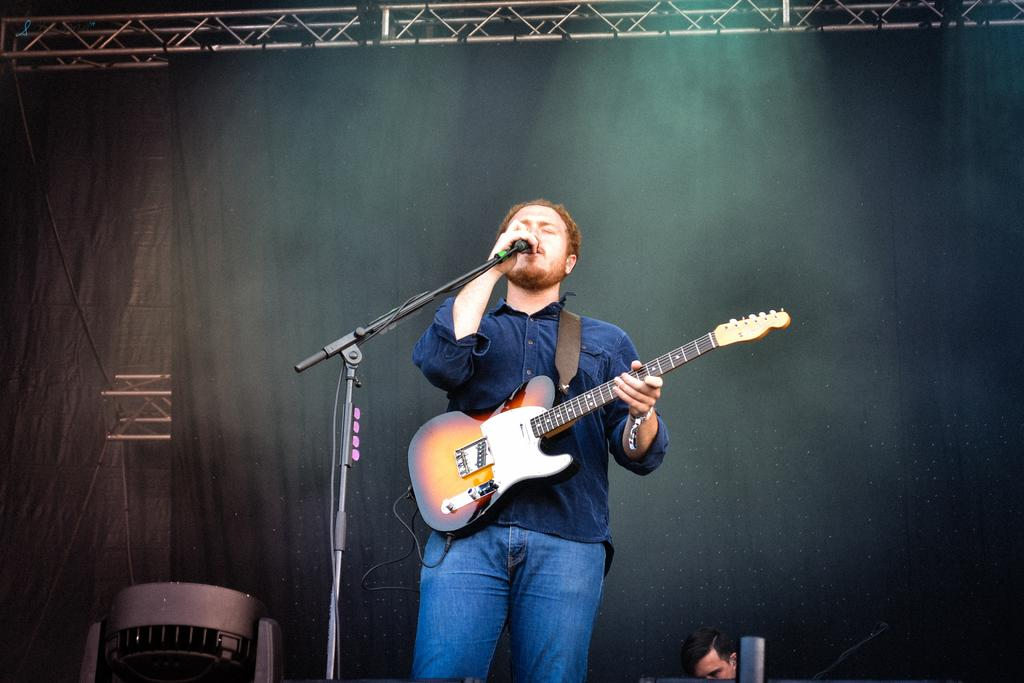What is the man in the image wearing? The man is wearing a blue shirt. What is the man doing in the image? The man is singing and holding a microphone. What instrument is the man carrying in the image? The man is carrying a guitar. What can be seen behind the man in the image? There is a curtain visible in the image. How many people are visible in the image? There is one person visible in the image, which is the man. What type of disgust can be seen on the man's face in the image? There is no indication of disgust on the man's face in the image; he appears to be singing and enjoying himself. 